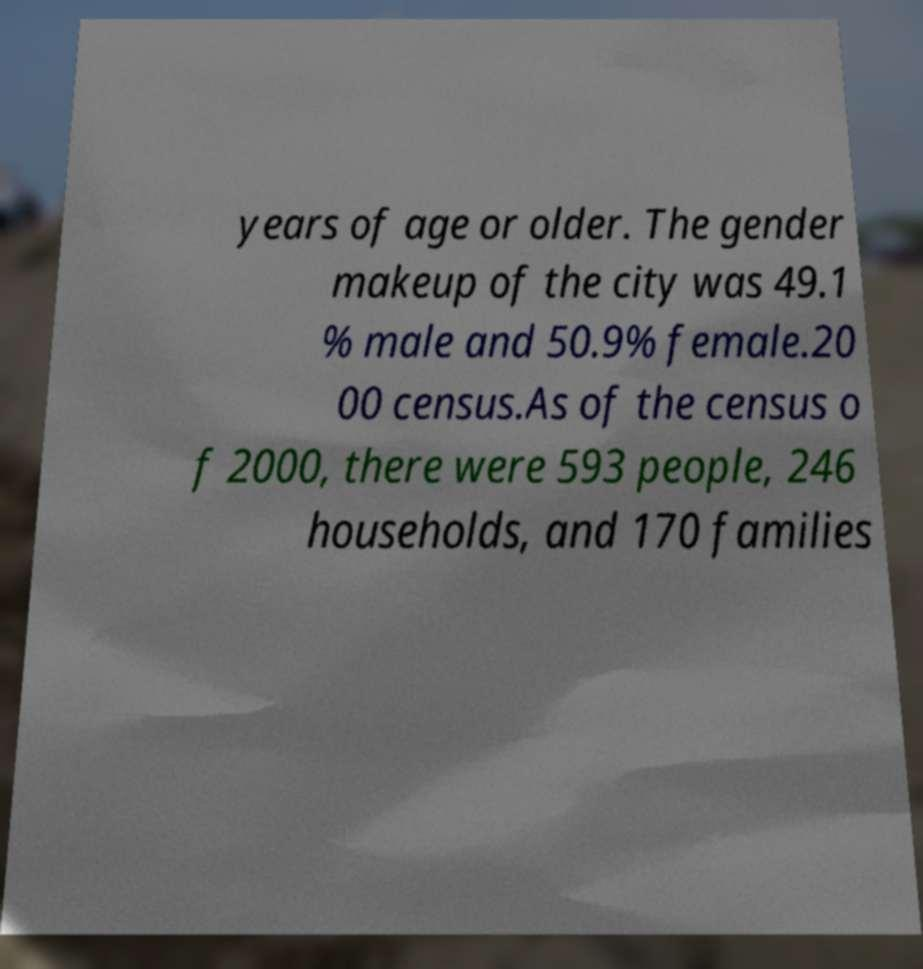There's text embedded in this image that I need extracted. Can you transcribe it verbatim? years of age or older. The gender makeup of the city was 49.1 % male and 50.9% female.20 00 census.As of the census o f 2000, there were 593 people, 246 households, and 170 families 